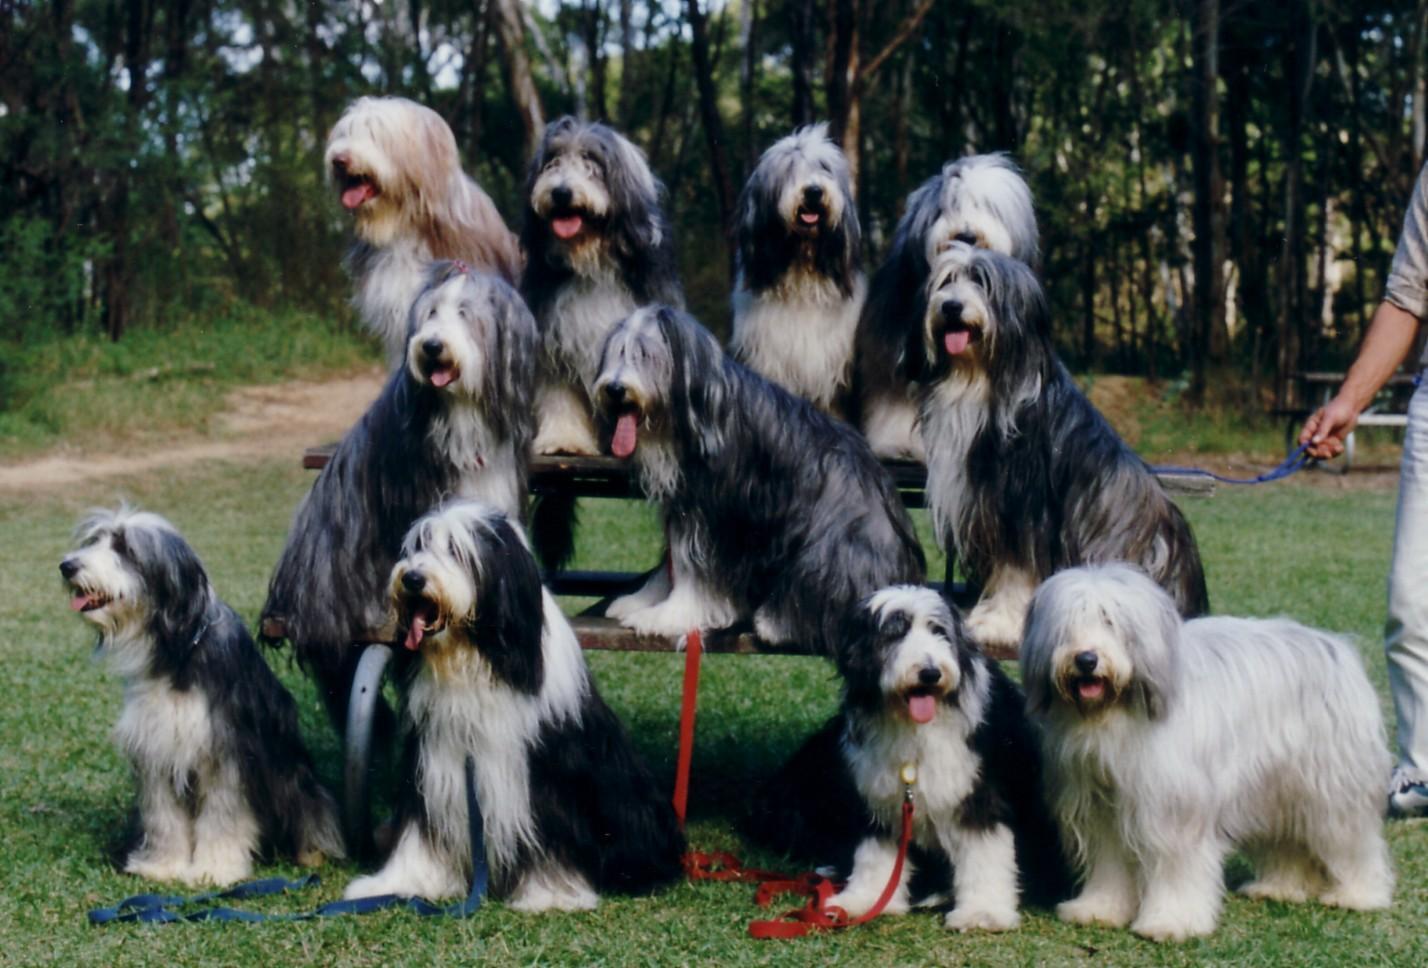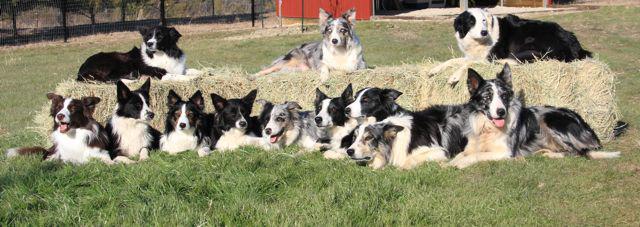The first image is the image on the left, the second image is the image on the right. Analyze the images presented: Is the assertion "There are at least seven dogs in the image on the right." valid? Answer yes or no. Yes. 